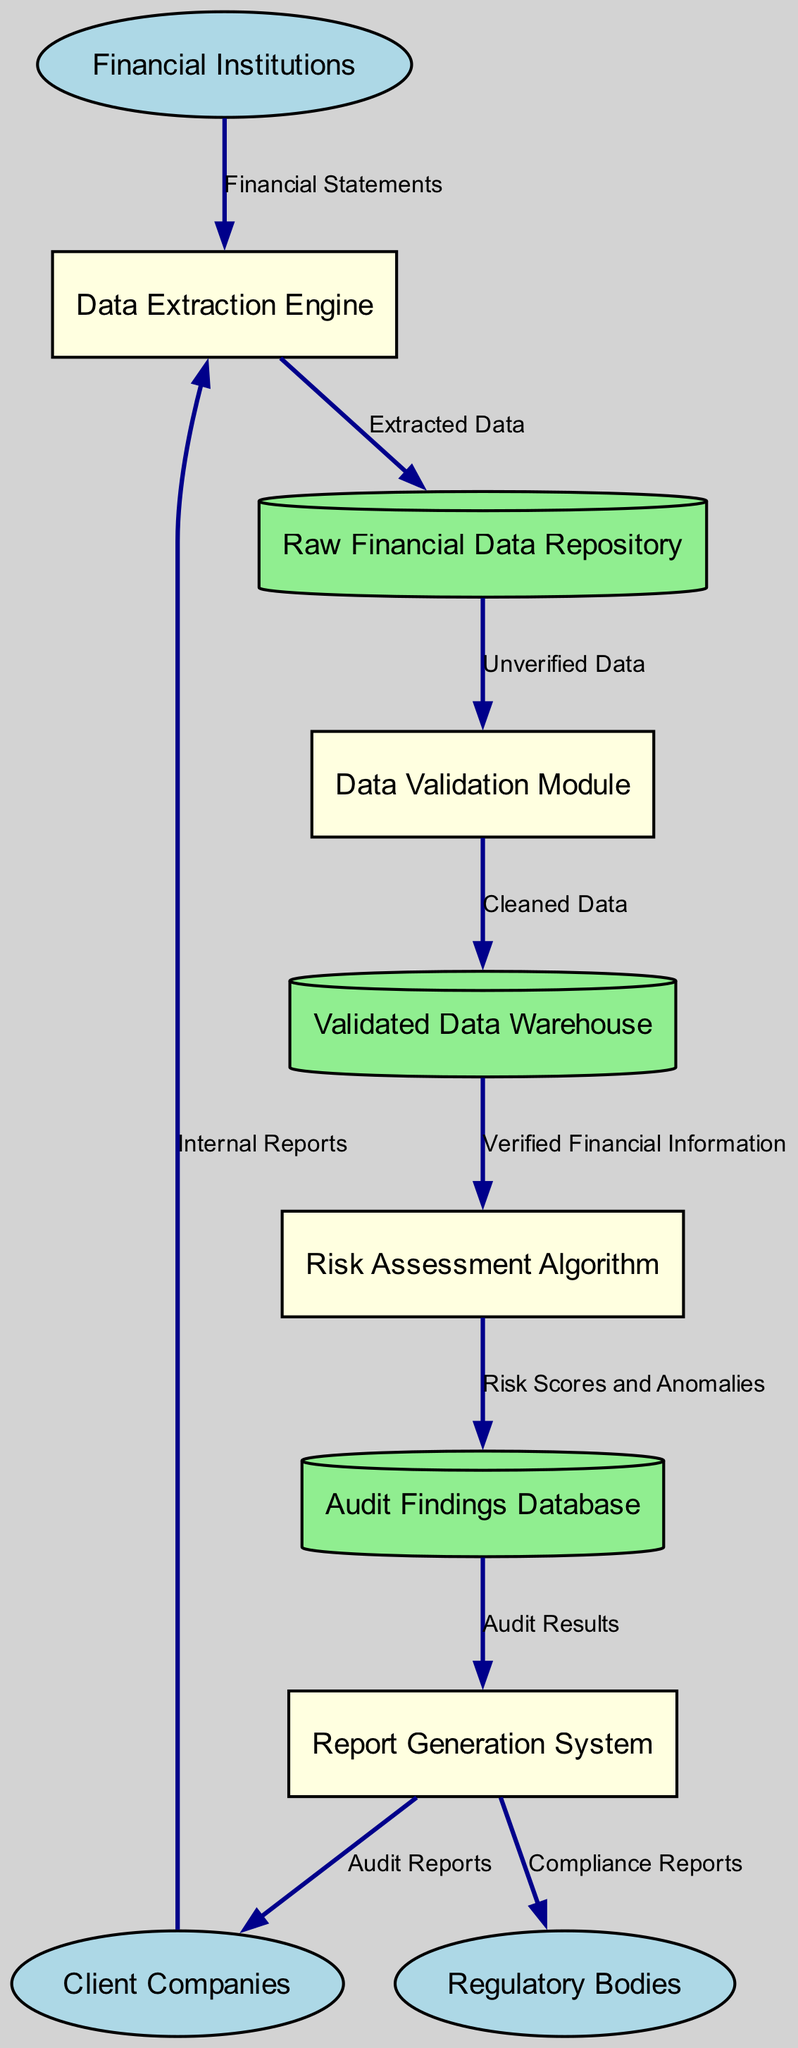What are the external entities in this system? The external entities listed in the diagram are Financial Institutions, Regulatory Bodies, and Client Companies. They interact with various processes in the system.
Answer: Financial Institutions, Regulatory Bodies, Client Companies How many processes are there in this diagram? The diagram features four distinct processes, which include the Data Extraction Engine, Data Validation Module, Risk Assessment Algorithm, and Report Generation System.
Answer: 4 What data flow comes from the Data Validation Module? The Data Validation Module sends a flow labeled "Cleaned Data" to the Validated Data Warehouse as part of its processing.
Answer: Cleaned Data Which external entity provides Internal Reports? The Client Companies are responsible for providing Internal Reports to the Data Extraction Engine, enabling the extraction of relevant financial data.
Answer: Client Companies What is the final output generated by the Report Generation System? The Report Generation System outputs both Compliance Reports directed to Regulatory Bodies and Audit Reports sent to Client Companies as its final deliverables.
Answer: Compliance Reports, Audit Reports What flows into the Risk Assessment Algorithm? The Risk Assessment Algorithm receives "Verified Financial Information" from the Validated Data Warehouse, which is the result of prior validation processes.
Answer: Verified Financial Information From which data store does the Data Validation Module receive data? The Data Validation Module receives "Unverified Data" from the Raw Financial Data Repository, which contains the initial extracted financial data before validation.
Answer: Raw Financial Data Repository Which process is responsible for generating audit results? The Report Generation System is the process tasked with generating audit results, which it retrieves from the Audit Findings Database.
Answer: Report Generation System How many data stores are in this diagram? The diagram contains three data stores: Raw Financial Data Repository, Validated Data Warehouse, and Audit Findings Database.
Answer: 3 What type of reports does the Report Generation System send to Client Companies? The Report Generation System sends Audit Reports to Client Companies, providing them with the results of the audit process.
Answer: Audit Reports 